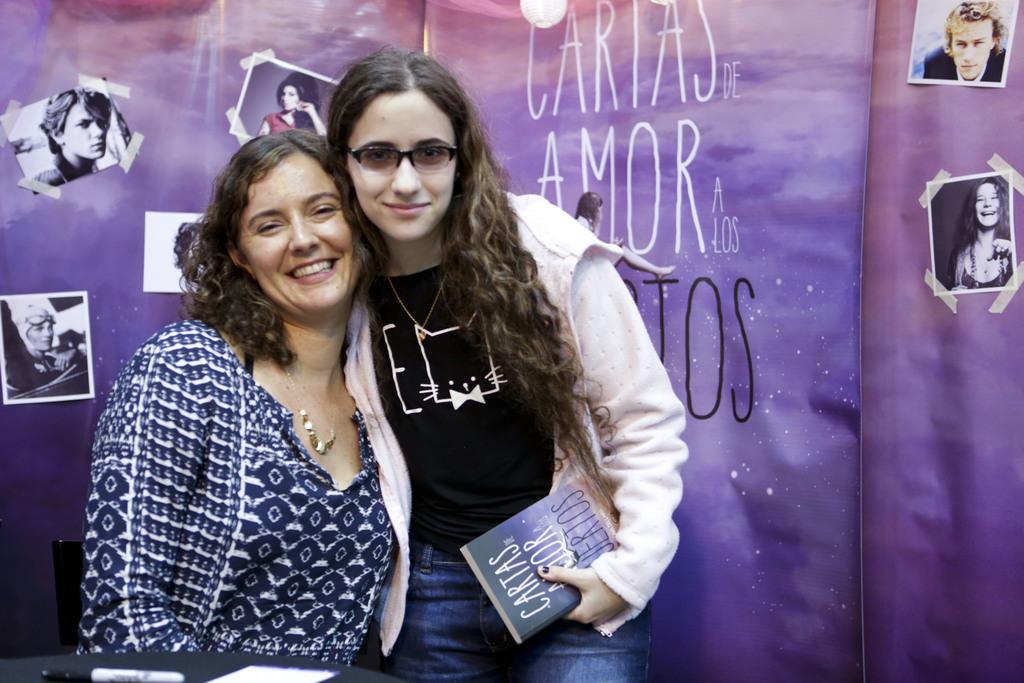Describe this image in one or two sentences. In this image we can see two ladies, one of them is holding a book, behind them there are photographs, and text on the cloth, in front of them there is a pen, and a paper on the table. 